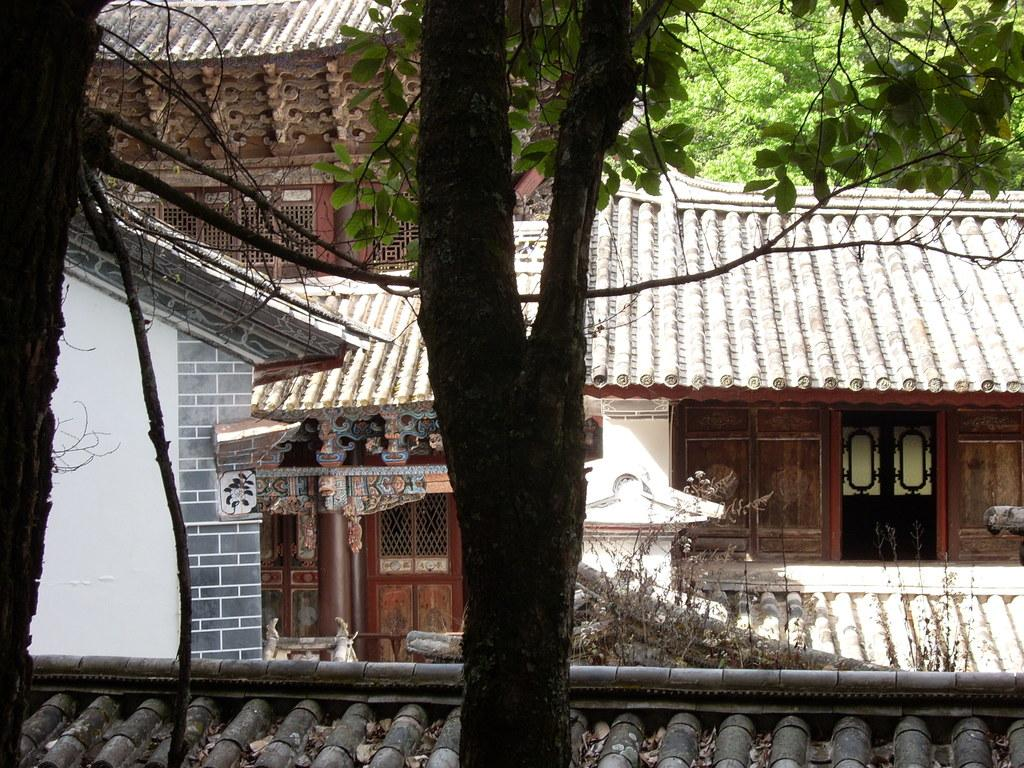What type of structures can be seen in the image? There are houses in the image. What type of vegetation is present in the image? There are trees in the image. Can you describe the cloud's shape in the image? There is no cloud present in the image. What type of body is visible in the image? There is no body present in the image; it features houses and trees. 